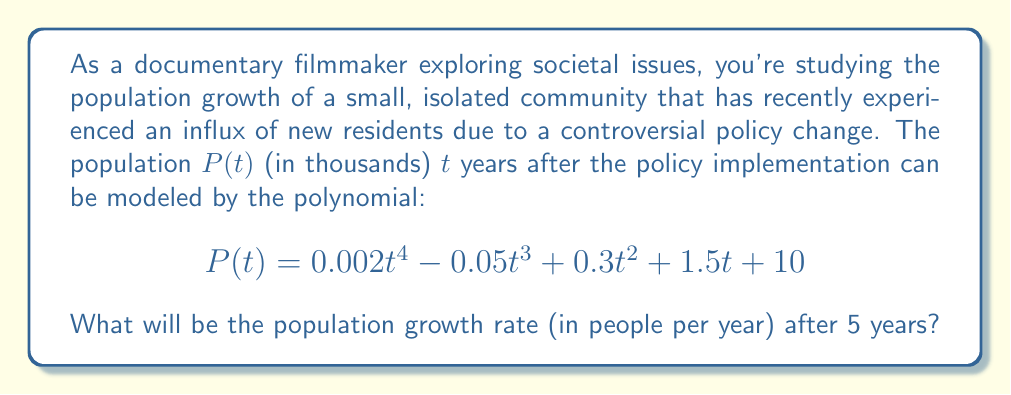Could you help me with this problem? To find the population growth rate after 5 years, we need to calculate the derivative of the population function $P(t)$ and evaluate it at $t=5$. This will give us the instantaneous rate of change at that point in time.

1. First, let's find the derivative of $P(t)$:
   $$P'(t) = 0.002 \cdot 4t^3 - 0.05 \cdot 3t^2 + 0.3 \cdot 2t + 1.5$$
   $$P'(t) = 0.008t^3 - 0.15t^2 + 0.6t + 1.5$$

2. Now, we evaluate $P'(5)$:
   $$P'(5) = 0.008(5^3) - 0.15(5^2) + 0.6(5) + 1.5$$
   $$P'(5) = 0.008(125) - 0.15(25) + 0.6(5) + 1.5$$
   $$P'(5) = 1 - 3.75 + 3 + 1.5$$
   $$P'(5) = 1.75$$

3. Remember that $P(t)$ is in thousands, so we need to multiply our result by 1000 to get the growth rate in people per year:
   $$1.75 \cdot 1000 = 1750$$

Therefore, after 5 years, the population will be growing at a rate of 1750 people per year.
Answer: 1750 people per year 